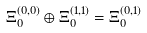Convert formula to latex. <formula><loc_0><loc_0><loc_500><loc_500>\Xi _ { 0 } ^ { ( 0 , 0 ) } \oplus \Xi _ { 0 } ^ { ( 1 , 1 ) } = \Xi _ { 0 } ^ { ( 0 , 1 ) }</formula> 